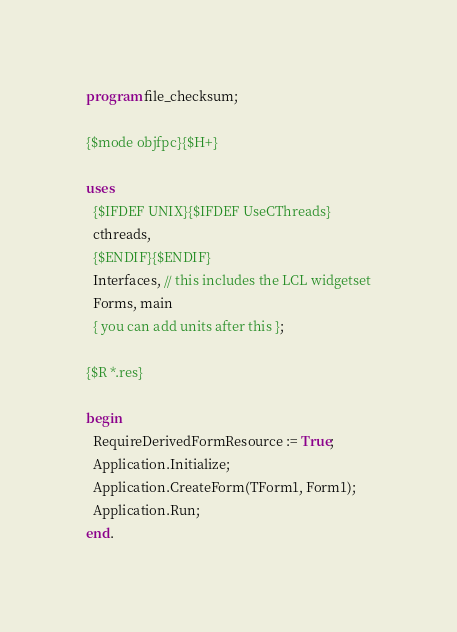<code> <loc_0><loc_0><loc_500><loc_500><_Pascal_>program file_checksum;

{$mode objfpc}{$H+}

uses
  {$IFDEF UNIX}{$IFDEF UseCThreads}
  cthreads,
  {$ENDIF}{$ENDIF}
  Interfaces, // this includes the LCL widgetset
  Forms, main
  { you can add units after this };

{$R *.res}

begin
  RequireDerivedFormResource := True;
  Application.Initialize;
  Application.CreateForm(TForm1, Form1);
  Application.Run;
end.

</code> 